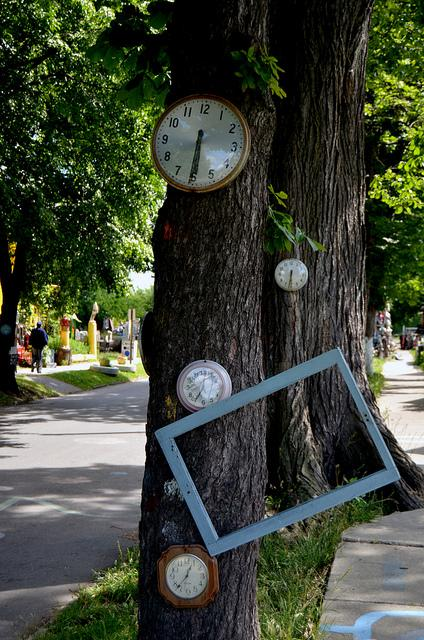What time can be seen on the highest clock?

Choices:
A) six thirty
B) twelve thirty
C) seven thirty
D) four thirty six thirty 